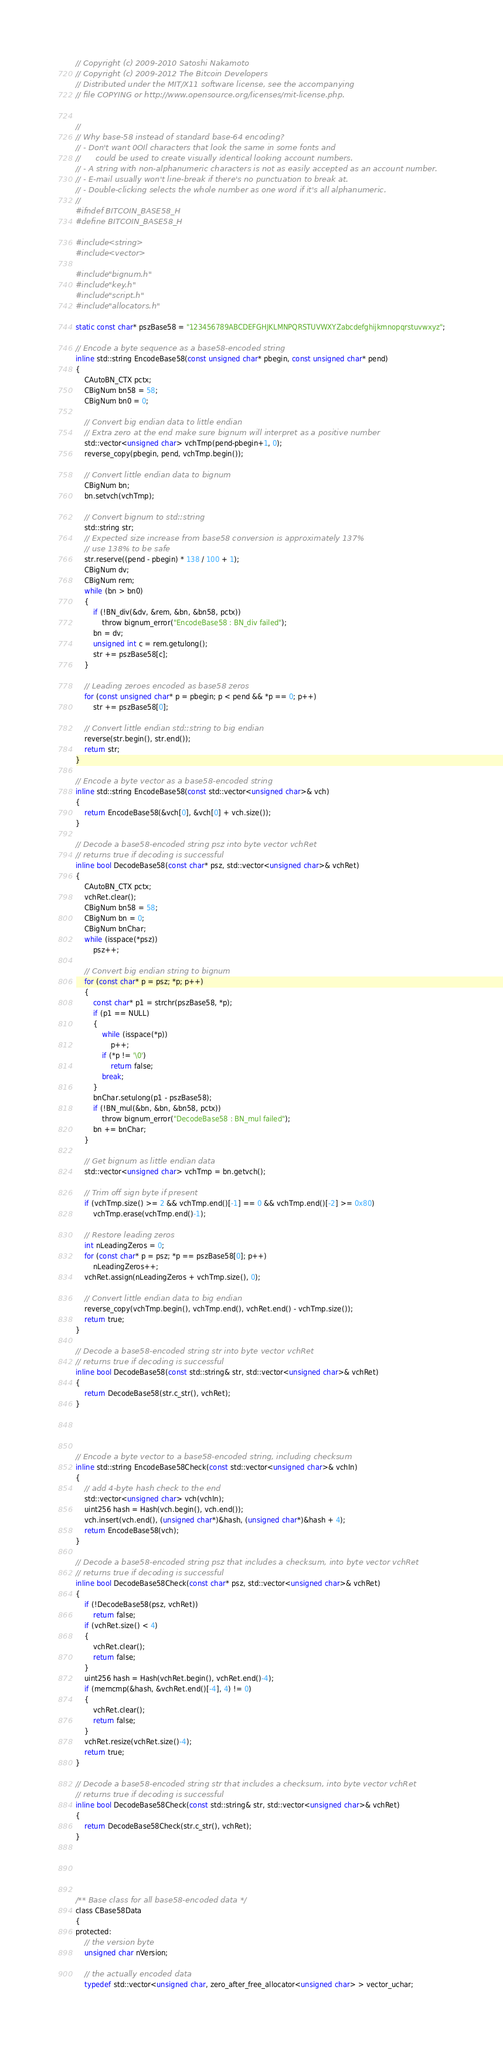<code> <loc_0><loc_0><loc_500><loc_500><_C_>// Copyright (c) 2009-2010 Satoshi Nakamoto
// Copyright (c) 2009-2012 The Bitcoin Developers
// Distributed under the MIT/X11 software license, see the accompanying
// file COPYING or http://www.opensource.org/licenses/mit-license.php.


//
// Why base-58 instead of standard base-64 encoding?
// - Don't want 0OIl characters that look the same in some fonts and
//      could be used to create visually identical looking account numbers.
// - A string with non-alphanumeric characters is not as easily accepted as an account number.
// - E-mail usually won't line-break if there's no punctuation to break at.
// - Double-clicking selects the whole number as one word if it's all alphanumeric.
//
#ifndef BITCOIN_BASE58_H
#define BITCOIN_BASE58_H

#include <string>
#include <vector>

#include "bignum.h"
#include "key.h"
#include "script.h"
#include "allocators.h"

static const char* pszBase58 = "123456789ABCDEFGHJKLMNPQRSTUVWXYZabcdefghijkmnopqrstuvwxyz";

// Encode a byte sequence as a base58-encoded string
inline std::string EncodeBase58(const unsigned char* pbegin, const unsigned char* pend)
{
    CAutoBN_CTX pctx;
    CBigNum bn58 = 58;
    CBigNum bn0 = 0;

    // Convert big endian data to little endian
    // Extra zero at the end make sure bignum will interpret as a positive number
    std::vector<unsigned char> vchTmp(pend-pbegin+1, 0);
    reverse_copy(pbegin, pend, vchTmp.begin());

    // Convert little endian data to bignum
    CBigNum bn;
    bn.setvch(vchTmp);

    // Convert bignum to std::string
    std::string str;
    // Expected size increase from base58 conversion is approximately 137%
    // use 138% to be safe
    str.reserve((pend - pbegin) * 138 / 100 + 1);
    CBigNum dv;
    CBigNum rem;
    while (bn > bn0)
    {
        if (!BN_div(&dv, &rem, &bn, &bn58, pctx))
            throw bignum_error("EncodeBase58 : BN_div failed");
        bn = dv;
        unsigned int c = rem.getulong();
        str += pszBase58[c];
    }

    // Leading zeroes encoded as base58 zeros
    for (const unsigned char* p = pbegin; p < pend && *p == 0; p++)
        str += pszBase58[0];

    // Convert little endian std::string to big endian
    reverse(str.begin(), str.end());
    return str;
}

// Encode a byte vector as a base58-encoded string
inline std::string EncodeBase58(const std::vector<unsigned char>& vch)
{
    return EncodeBase58(&vch[0], &vch[0] + vch.size());
}

// Decode a base58-encoded string psz into byte vector vchRet
// returns true if decoding is successful
inline bool DecodeBase58(const char* psz, std::vector<unsigned char>& vchRet)
{
    CAutoBN_CTX pctx;
    vchRet.clear();
    CBigNum bn58 = 58;
    CBigNum bn = 0;
    CBigNum bnChar;
    while (isspace(*psz))
        psz++;

    // Convert big endian string to bignum
    for (const char* p = psz; *p; p++)
    {
        const char* p1 = strchr(pszBase58, *p);
        if (p1 == NULL)
        {
            while (isspace(*p))
                p++;
            if (*p != '\0')
                return false;
            break;
        }
        bnChar.setulong(p1 - pszBase58);
        if (!BN_mul(&bn, &bn, &bn58, pctx))
            throw bignum_error("DecodeBase58 : BN_mul failed");
        bn += bnChar;
    }

    // Get bignum as little endian data
    std::vector<unsigned char> vchTmp = bn.getvch();

    // Trim off sign byte if present
    if (vchTmp.size() >= 2 && vchTmp.end()[-1] == 0 && vchTmp.end()[-2] >= 0x80)
        vchTmp.erase(vchTmp.end()-1);

    // Restore leading zeros
    int nLeadingZeros = 0;
    for (const char* p = psz; *p == pszBase58[0]; p++)
        nLeadingZeros++;
    vchRet.assign(nLeadingZeros + vchTmp.size(), 0);

    // Convert little endian data to big endian
    reverse_copy(vchTmp.begin(), vchTmp.end(), vchRet.end() - vchTmp.size());
    return true;
}

// Decode a base58-encoded string str into byte vector vchRet
// returns true if decoding is successful
inline bool DecodeBase58(const std::string& str, std::vector<unsigned char>& vchRet)
{
    return DecodeBase58(str.c_str(), vchRet);
}




// Encode a byte vector to a base58-encoded string, including checksum
inline std::string EncodeBase58Check(const std::vector<unsigned char>& vchIn)
{
    // add 4-byte hash check to the end
    std::vector<unsigned char> vch(vchIn);
    uint256 hash = Hash(vch.begin(), vch.end());
    vch.insert(vch.end(), (unsigned char*)&hash, (unsigned char*)&hash + 4);
    return EncodeBase58(vch);
}

// Decode a base58-encoded string psz that includes a checksum, into byte vector vchRet
// returns true if decoding is successful
inline bool DecodeBase58Check(const char* psz, std::vector<unsigned char>& vchRet)
{
    if (!DecodeBase58(psz, vchRet))
        return false;
    if (vchRet.size() < 4)
    {
        vchRet.clear();
        return false;
    }
    uint256 hash = Hash(vchRet.begin(), vchRet.end()-4);
    if (memcmp(&hash, &vchRet.end()[-4], 4) != 0)
    {
        vchRet.clear();
        return false;
    }
    vchRet.resize(vchRet.size()-4);
    return true;
}

// Decode a base58-encoded string str that includes a checksum, into byte vector vchRet
// returns true if decoding is successful
inline bool DecodeBase58Check(const std::string& str, std::vector<unsigned char>& vchRet)
{
    return DecodeBase58Check(str.c_str(), vchRet);
}





/** Base class for all base58-encoded data */
class CBase58Data
{
protected:
    // the version byte
    unsigned char nVersion;

    // the actually encoded data
    typedef std::vector<unsigned char, zero_after_free_allocator<unsigned char> > vector_uchar;</code> 